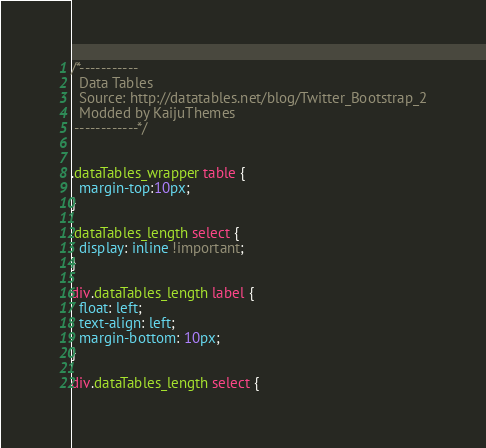<code> <loc_0><loc_0><loc_500><loc_500><_CSS_>/*-----------
  Data Tables 
  Source: http://datatables.net/blog/Twitter_Bootstrap_2
  Modded by KaijuThemes
 ------------*/


.dataTables_wrapper table {
  margin-top:10px;
}

.dataTables_length select {
  display: inline !important;
}

div.dataTables_length label {
  float: left;
  text-align: left;
  margin-bottom: 10px;
}

div.dataTables_length select {</code> 